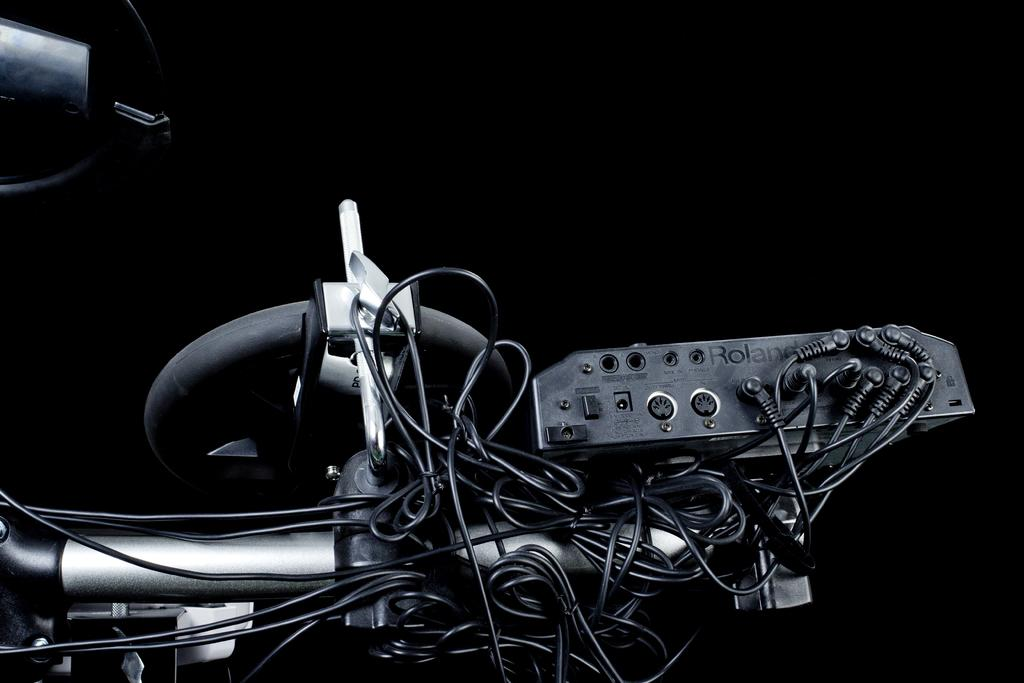What is the main subject of the picture? The main subject of the picture is an electronic machine. Are there any additional features of the electronic machine? Yes, the electronic machine has wires attached to it. What is the color of the background in the image? The backdrop of the image is dark. Can you tell me how many cubs are playing with the electronic machine in the image? There are no cubs present in the image, and therefore no such activity can be observed. 